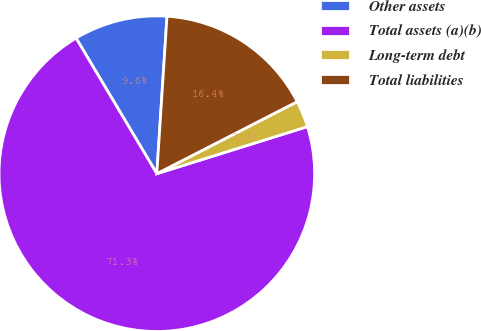Convert chart to OTSL. <chart><loc_0><loc_0><loc_500><loc_500><pie_chart><fcel>Other assets<fcel>Total assets (a)(b)<fcel>Long-term debt<fcel>Total liabilities<nl><fcel>9.58%<fcel>71.27%<fcel>2.72%<fcel>16.43%<nl></chart> 